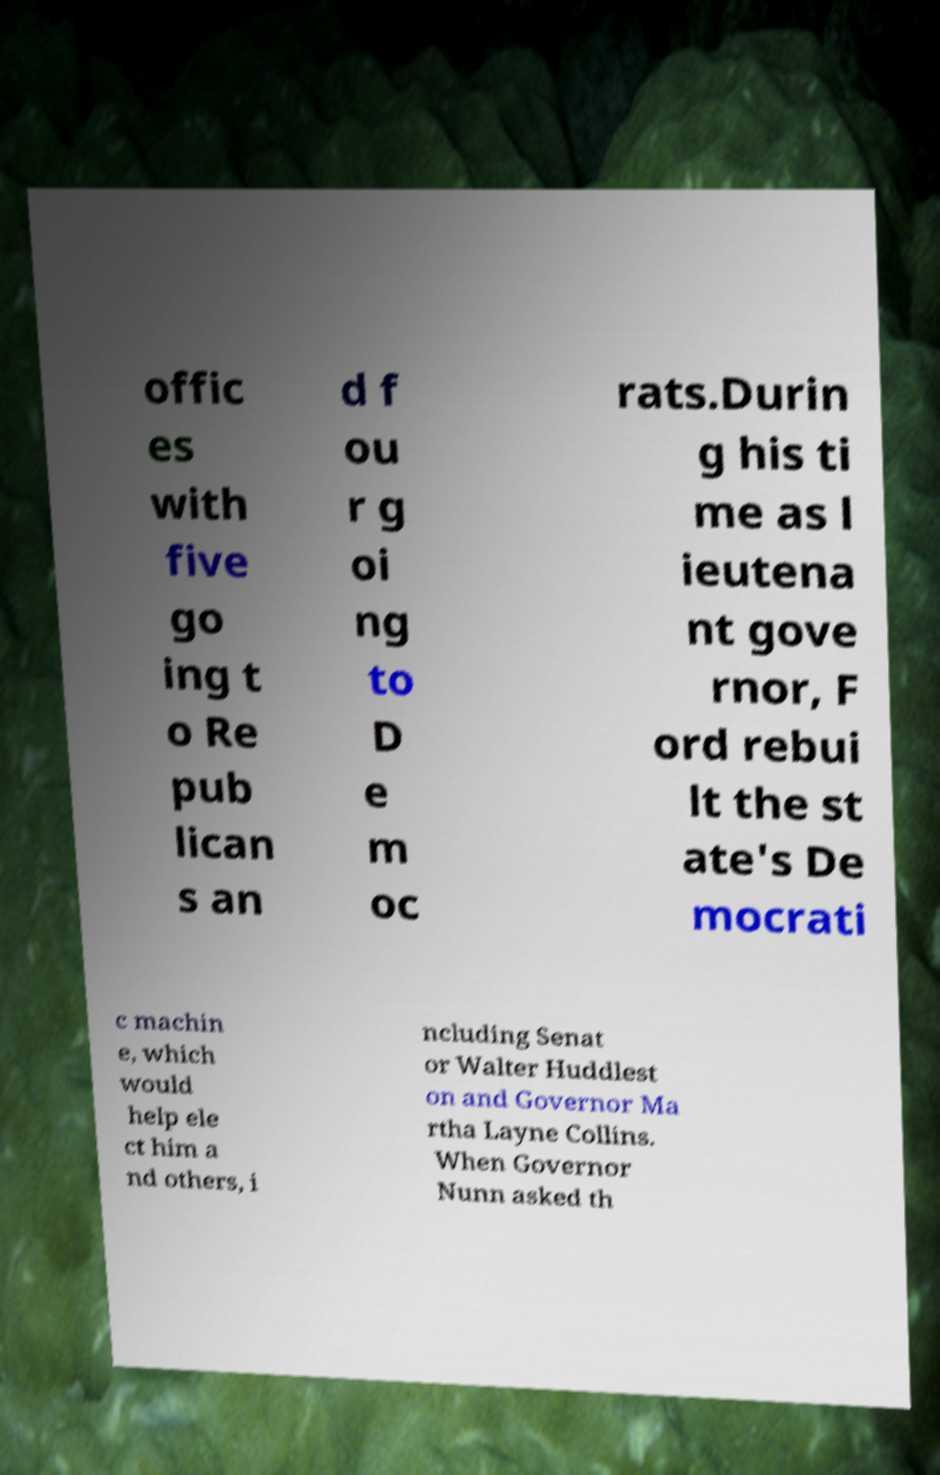I need the written content from this picture converted into text. Can you do that? offic es with five go ing t o Re pub lican s an d f ou r g oi ng to D e m oc rats.Durin g his ti me as l ieutena nt gove rnor, F ord rebui lt the st ate's De mocrati c machin e, which would help ele ct him a nd others, i ncluding Senat or Walter Huddlest on and Governor Ma rtha Layne Collins. When Governor Nunn asked th 